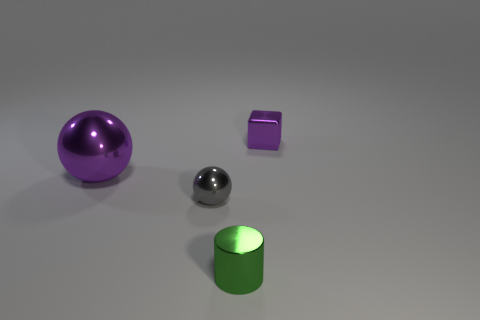Are there any other things that have the same size as the purple ball?
Give a very brief answer. No. There is a purple metal object that is to the right of the cylinder; does it have the same size as the green metallic cylinder?
Offer a very short reply. Yes. How many other objects are there of the same size as the purple shiny sphere?
Make the answer very short. 0. The tiny cylinder is what color?
Give a very brief answer. Green. Is the number of small purple metal cubes to the right of the purple metallic cube the same as the number of tiny shiny cubes?
Offer a terse response. No. Does the tiny gray metallic object have the same shape as the tiny purple shiny thing?
Give a very brief answer. No. Is there any other thing of the same color as the large thing?
Make the answer very short. Yes. There is a thing that is on the left side of the small green cylinder and behind the gray sphere; what is its shape?
Your answer should be very brief. Sphere. Are there the same number of objects that are to the right of the small green metallic cylinder and metallic cubes that are left of the big object?
Provide a succinct answer. No. How many cylinders are small metallic things or green shiny things?
Provide a succinct answer. 1. 